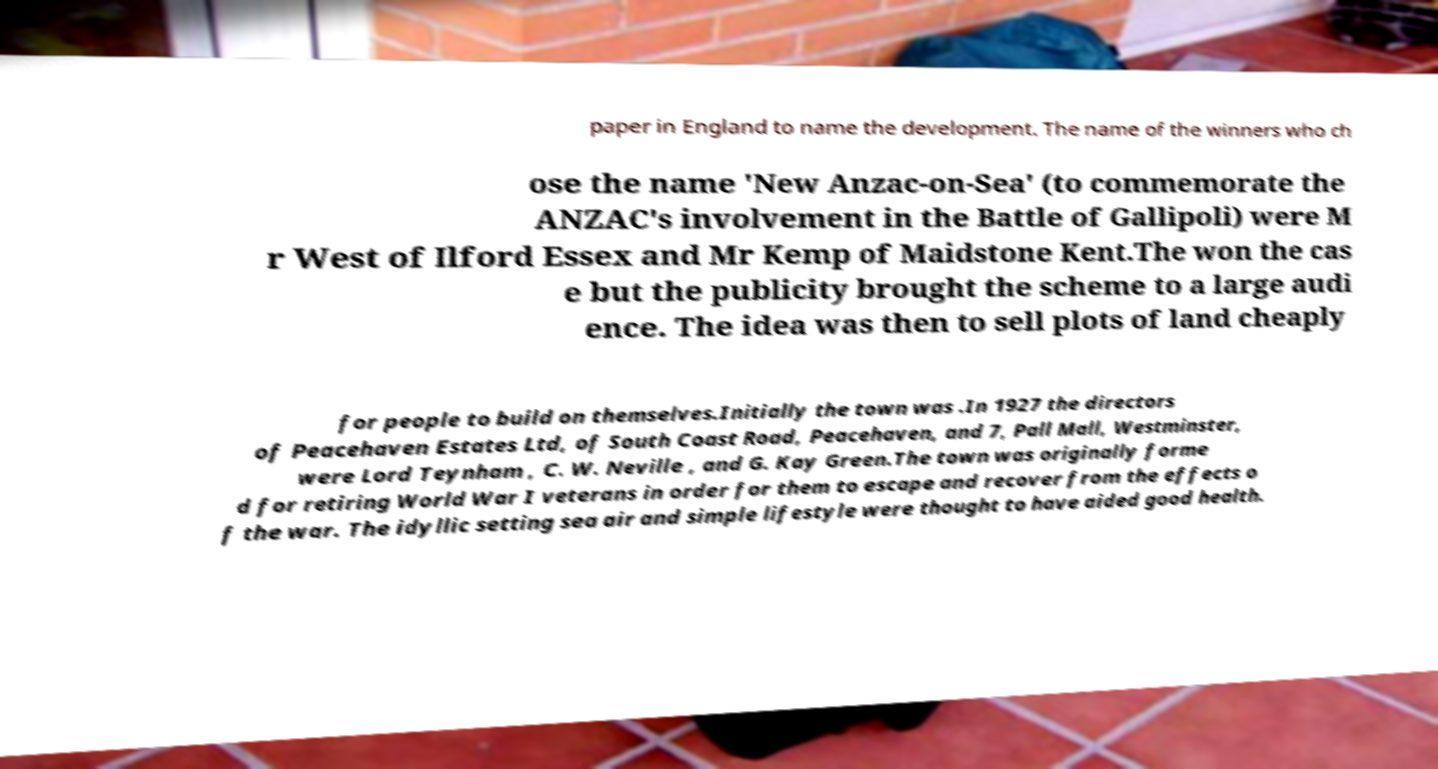Please identify and transcribe the text found in this image. paper in England to name the development. The name of the winners who ch ose the name 'New Anzac-on-Sea' (to commemorate the ANZAC's involvement in the Battle of Gallipoli) were M r West of Ilford Essex and Mr Kemp of Maidstone Kent.The won the cas e but the publicity brought the scheme to a large audi ence. The idea was then to sell plots of land cheaply for people to build on themselves.Initially the town was .In 1927 the directors of Peacehaven Estates Ltd, of South Coast Road, Peacehaven, and 7, Pall Mall, Westminster, were Lord Teynham , C. W. Neville , and G. Kay Green.The town was originally forme d for retiring World War I veterans in order for them to escape and recover from the effects o f the war. The idyllic setting sea air and simple lifestyle were thought to have aided good health. 